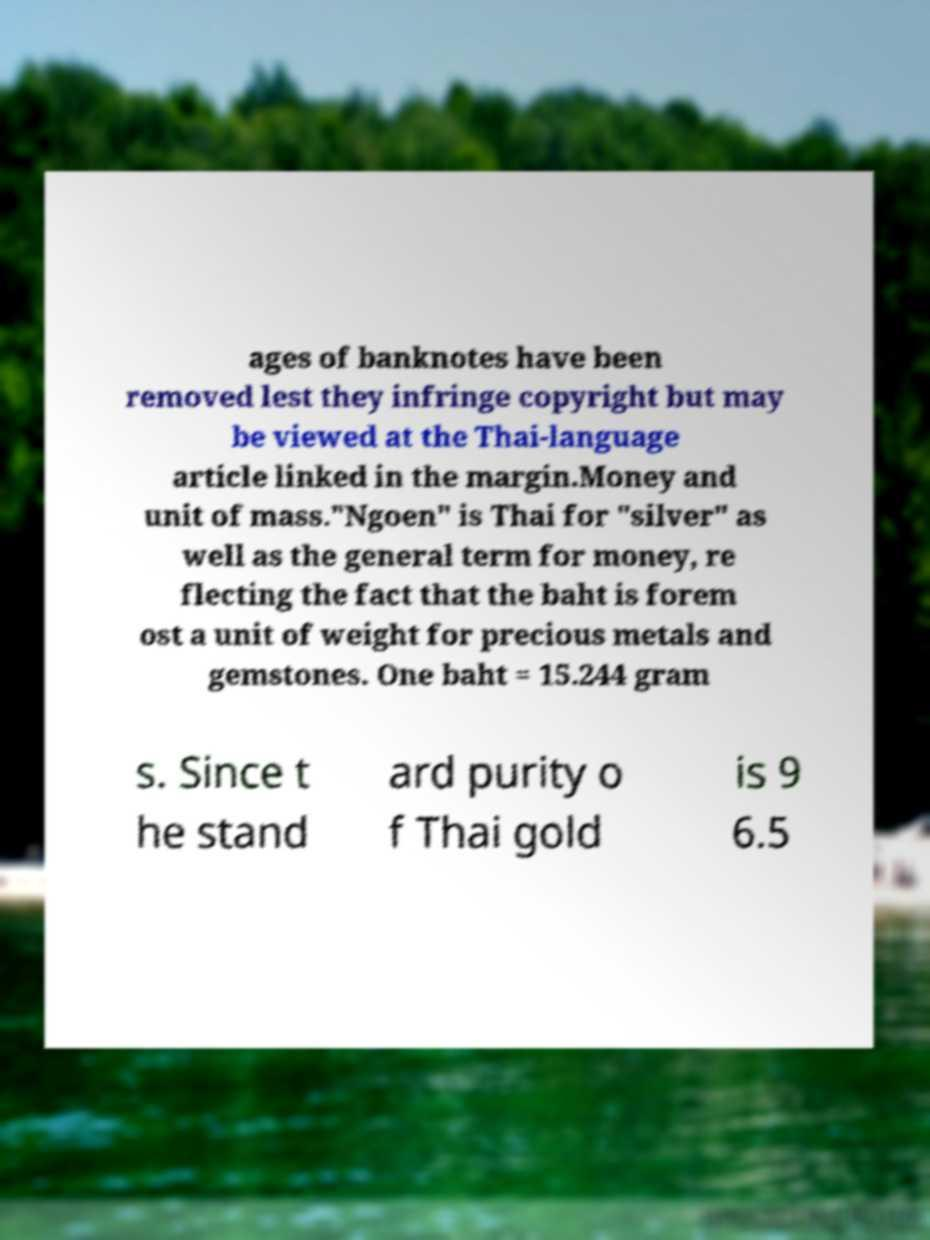Please identify and transcribe the text found in this image. ages of banknotes have been removed lest they infringe copyright but may be viewed at the Thai-language article linked in the margin.Money and unit of mass."Ngoen" is Thai for "silver" as well as the general term for money, re flecting the fact that the baht is forem ost a unit of weight for precious metals and gemstones. One baht = 15.244 gram s. Since t he stand ard purity o f Thai gold is 9 6.5 